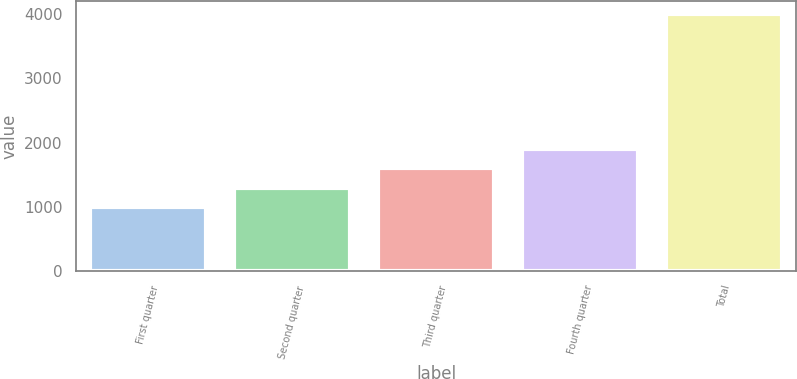Convert chart. <chart><loc_0><loc_0><loc_500><loc_500><bar_chart><fcel>First quarter<fcel>Second quarter<fcel>Third quarter<fcel>Fourth quarter<fcel>Total<nl><fcel>1000<fcel>1300<fcel>1600<fcel>1900<fcel>4000<nl></chart> 